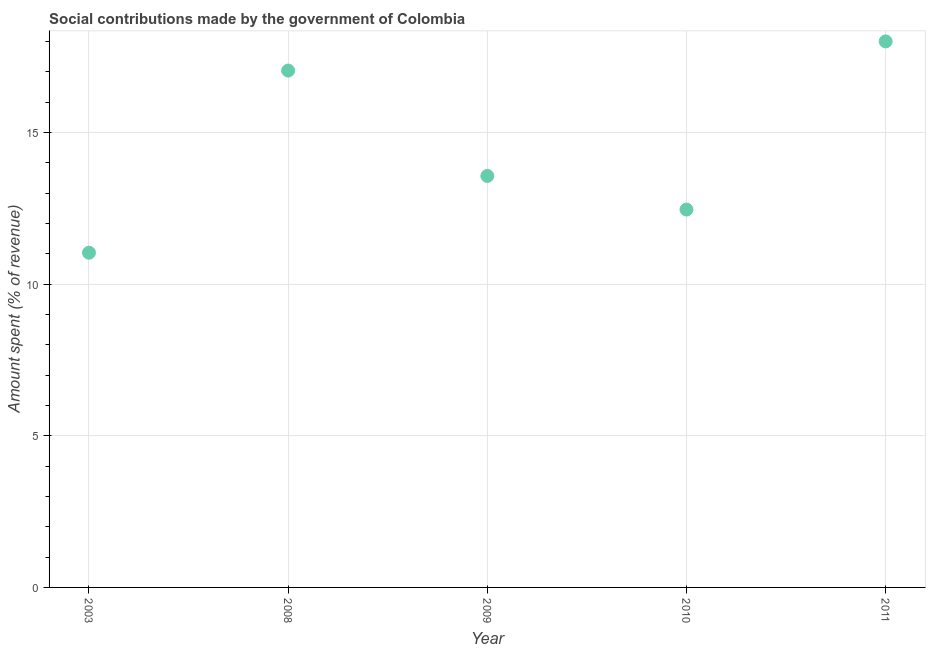What is the amount spent in making social contributions in 2009?
Your answer should be compact. 13.57. Across all years, what is the maximum amount spent in making social contributions?
Your answer should be very brief. 18. Across all years, what is the minimum amount spent in making social contributions?
Offer a terse response. 11.04. In which year was the amount spent in making social contributions maximum?
Provide a succinct answer. 2011. In which year was the amount spent in making social contributions minimum?
Give a very brief answer. 2003. What is the sum of the amount spent in making social contributions?
Offer a terse response. 72.1. What is the difference between the amount spent in making social contributions in 2003 and 2009?
Ensure brevity in your answer.  -2.53. What is the average amount spent in making social contributions per year?
Keep it short and to the point. 14.42. What is the median amount spent in making social contributions?
Make the answer very short. 13.57. In how many years, is the amount spent in making social contributions greater than 14 %?
Provide a succinct answer. 2. Do a majority of the years between 2011 and 2010 (inclusive) have amount spent in making social contributions greater than 3 %?
Offer a terse response. No. What is the ratio of the amount spent in making social contributions in 2003 to that in 2009?
Offer a terse response. 0.81. Is the amount spent in making social contributions in 2010 less than that in 2011?
Your answer should be very brief. Yes. What is the difference between the highest and the second highest amount spent in making social contributions?
Ensure brevity in your answer.  0.96. What is the difference between the highest and the lowest amount spent in making social contributions?
Your answer should be compact. 6.97. In how many years, is the amount spent in making social contributions greater than the average amount spent in making social contributions taken over all years?
Provide a short and direct response. 2. How many dotlines are there?
Ensure brevity in your answer.  1. Does the graph contain any zero values?
Provide a succinct answer. No. Does the graph contain grids?
Give a very brief answer. Yes. What is the title of the graph?
Ensure brevity in your answer.  Social contributions made by the government of Colombia. What is the label or title of the X-axis?
Keep it short and to the point. Year. What is the label or title of the Y-axis?
Ensure brevity in your answer.  Amount spent (% of revenue). What is the Amount spent (% of revenue) in 2003?
Make the answer very short. 11.04. What is the Amount spent (% of revenue) in 2008?
Keep it short and to the point. 17.04. What is the Amount spent (% of revenue) in 2009?
Your answer should be very brief. 13.57. What is the Amount spent (% of revenue) in 2010?
Ensure brevity in your answer.  12.46. What is the Amount spent (% of revenue) in 2011?
Your answer should be very brief. 18. What is the difference between the Amount spent (% of revenue) in 2003 and 2008?
Your answer should be very brief. -6. What is the difference between the Amount spent (% of revenue) in 2003 and 2009?
Provide a short and direct response. -2.53. What is the difference between the Amount spent (% of revenue) in 2003 and 2010?
Make the answer very short. -1.42. What is the difference between the Amount spent (% of revenue) in 2003 and 2011?
Your answer should be compact. -6.97. What is the difference between the Amount spent (% of revenue) in 2008 and 2009?
Provide a succinct answer. 3.47. What is the difference between the Amount spent (% of revenue) in 2008 and 2010?
Offer a very short reply. 4.58. What is the difference between the Amount spent (% of revenue) in 2008 and 2011?
Offer a terse response. -0.96. What is the difference between the Amount spent (% of revenue) in 2009 and 2010?
Give a very brief answer. 1.11. What is the difference between the Amount spent (% of revenue) in 2009 and 2011?
Your answer should be compact. -4.44. What is the difference between the Amount spent (% of revenue) in 2010 and 2011?
Make the answer very short. -5.54. What is the ratio of the Amount spent (% of revenue) in 2003 to that in 2008?
Offer a very short reply. 0.65. What is the ratio of the Amount spent (% of revenue) in 2003 to that in 2009?
Your answer should be very brief. 0.81. What is the ratio of the Amount spent (% of revenue) in 2003 to that in 2010?
Provide a succinct answer. 0.89. What is the ratio of the Amount spent (% of revenue) in 2003 to that in 2011?
Keep it short and to the point. 0.61. What is the ratio of the Amount spent (% of revenue) in 2008 to that in 2009?
Provide a short and direct response. 1.26. What is the ratio of the Amount spent (% of revenue) in 2008 to that in 2010?
Keep it short and to the point. 1.37. What is the ratio of the Amount spent (% of revenue) in 2008 to that in 2011?
Keep it short and to the point. 0.95. What is the ratio of the Amount spent (% of revenue) in 2009 to that in 2010?
Provide a short and direct response. 1.09. What is the ratio of the Amount spent (% of revenue) in 2009 to that in 2011?
Provide a succinct answer. 0.75. What is the ratio of the Amount spent (% of revenue) in 2010 to that in 2011?
Your answer should be compact. 0.69. 